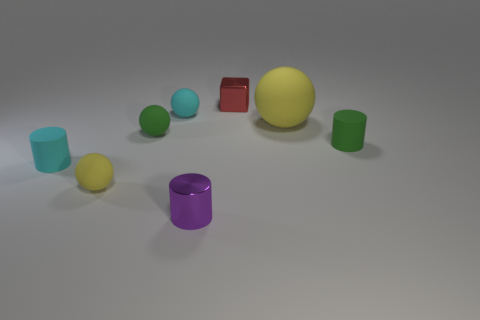There is a red metal object; are there any tiny cyan matte cylinders right of it?
Your answer should be very brief. No. There is a metallic thing behind the cyan cylinder; is there a small red metallic thing in front of it?
Provide a short and direct response. No. Is the number of small purple cylinders that are behind the green cylinder less than the number of big yellow objects that are to the right of the big yellow thing?
Offer a very short reply. No. There is a red thing; what shape is it?
Ensure brevity in your answer.  Cube. What is the material of the purple object in front of the small green rubber ball?
Keep it short and to the point. Metal. What is the size of the yellow object on the right side of the tiny cyan thing behind the tiny green cylinder in front of the large yellow ball?
Provide a short and direct response. Large. Does the big sphere that is on the right side of the green sphere have the same material as the red object to the right of the small purple metal cylinder?
Your response must be concise. No. What number of other objects are the same color as the small shiny cylinder?
Provide a succinct answer. 0. How many things are green matte things that are behind the small green cylinder or things in front of the red shiny thing?
Make the answer very short. 7. How big is the yellow matte thing that is behind the small cylinder that is behind the small cyan cylinder?
Offer a terse response. Large. 